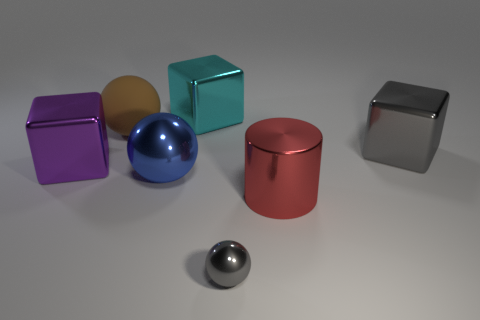What number of cubes are either small green metal things or large brown rubber things?
Offer a terse response. 0. There is a gray metallic object left of the red thing; does it have the same shape as the gray metallic object behind the tiny object?
Offer a very short reply. No. What is the material of the big brown thing?
Offer a terse response. Rubber. How many gray things have the same size as the purple object?
Your answer should be very brief. 1. What number of things are either blocks that are on the left side of the large gray shiny cube or big cubes behind the blue ball?
Your response must be concise. 3. Does the object that is behind the brown ball have the same material as the sphere behind the big gray block?
Provide a short and direct response. No. What is the shape of the gray shiny thing that is in front of the gray metallic object that is behind the blue shiny thing?
Your answer should be compact. Sphere. Is there any other thing of the same color as the cylinder?
Your answer should be compact. No. There is a large red cylinder in front of the large metallic block that is on the left side of the cyan block; is there a big purple block that is in front of it?
Ensure brevity in your answer.  No. Does the big shiny cube on the right side of the small gray object have the same color as the sphere in front of the red cylinder?
Your response must be concise. Yes. 